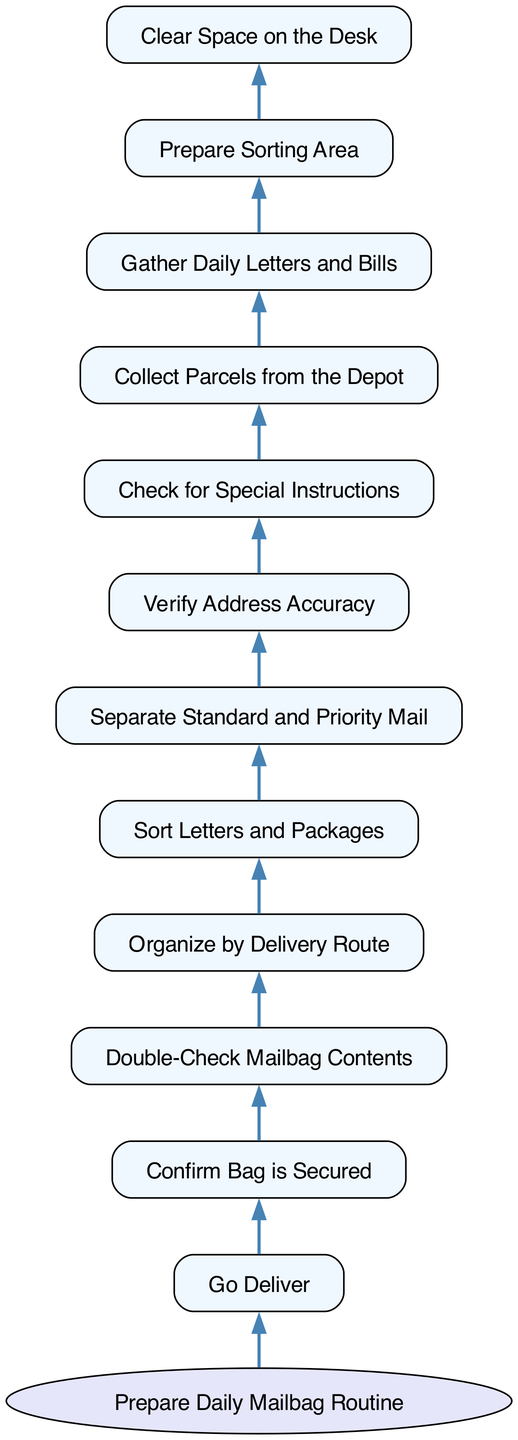What is the first step in the routine? The routine begins with "Prepare Daily Mailbag Routine". This is the top node in the diagram, which indicates the starting point for the entire process.
Answer: Prepare Daily Mailbag Routine How many nodes are in the diagram? By counting each individual step and the main routine, there are 11 nodes representing different actions in the preparation routine. Each action is represented as a node in the flowchart.
Answer: 11 Which node follows "Check for Special Instructions"? The node that follows "Check for Special Instructions" is "Verify Address Accuracy." Following the flow of the diagram, this step comes directly after checking for any special instructions regarding the delivery.
Answer: Verify Address Accuracy What is the last action taken before going to deliver? The last action taken before "Go Deliver" is "Confirm Bag is Secured." This node is crucial as it ensures that the mailbag is properly secured before proceeding with delivery.
Answer: Confirm Bag is Secured List the steps leading up to sorting letters and packages. The steps leading up to "Sort Letters and Packages" are "Prepare Daily Mailbag Routine," "Collect Parcels from the Depot," "Gather Daily Letters and Bills," and "Prepare Sorting Area." This shows the sequence of actions that culminate in sorting.
Answer: Prepare Daily Mailbag Routine, Collect Parcels from the Depot, Gather Daily Letters and Bills, Prepare Sorting Area What type of mail is separated during the sorting process? During the sorting process, "Standard and Priority Mail" are separated. This step highlights the need to distinguish between regular deliveries and those that require faster service.
Answer: Standard and Priority Mail What is the relationship between "Organize by Delivery Route" and "Sort Letters and Packages"? "Organize by Delivery Route" is a prerequisite step that must occur before "Sort Letters and Packages." This indicates that after organizing, the letters and packages are sorted based on the planned delivery paths.
Answer: Organize by Delivery Route precedes Sort Letters and Packages Which node is the second step of the routine? The second step in the routine is "Collect Parcels from the Depot." After preparing the mailbag, the next action involves collecting parcels needed for delivery.
Answer: Collect Parcels from the Depot What is required before "Go Deliver"? Before "Go Deliver," all prior steps (such as confirming the bag is secured and double-checking the mailbag contents) must be completed. This ensures that everything is in order for successful delivery.
Answer: All prior steps must be completed 